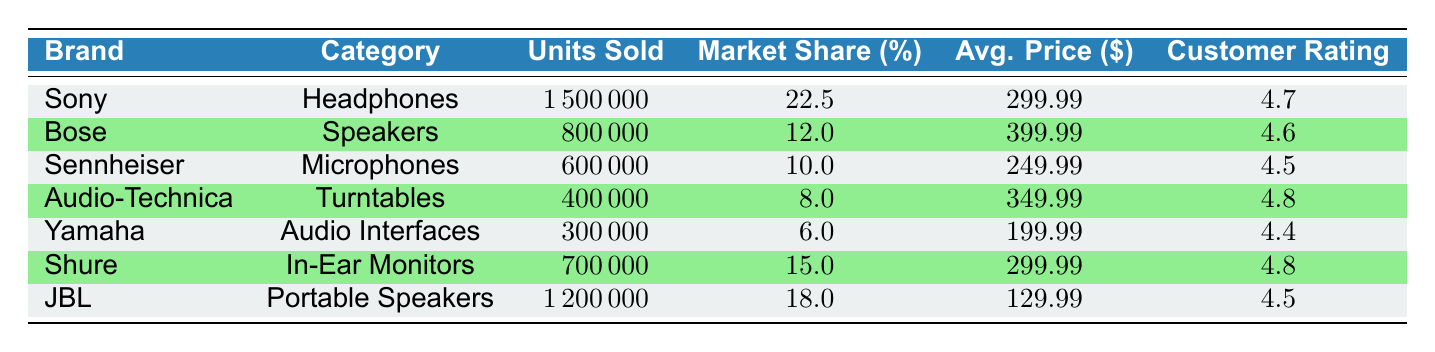What audio brand had the highest market share in 2022? From the table, Sony has a market share of 22.5%, which is the highest among all brands listed.
Answer: Sony How many units of Audio-Technica turntables were sold? Looking at the table, Audio-Technica sold 400,000 units of turntables.
Answer: 400000 Is the average price of JBL portable speakers lower than that of Yamaha audio interfaces? The average price of JBL portable speakers is 129.99, while Yamaha audio interfaces cost 199.99. Since 129.99 < 199.99, the statement is true.
Answer: Yes What is the total number of units sold for Shure in-ear monitors and Sennheiser microphones combined? Shure sold 700,000 units, and Sennheiser sold 600,000 units. Adding these together gives 700,000 + 600,000 = 1,300,000 units.
Answer: 1300000 Which brand achieved a customer rating of 4.8? The table shows that both Audio-Technica and Shure received a customer rating of 4.8.
Answer: Audio-Technica, Shure What brand has the second highest units sold after Sony? After checking the units sold, JBL has 1,200,000 units sold, making it the second highest, following Sony's 1,500,000 units.
Answer: JBL Did Bose have a higher average price compared to Sennheiser? The average price of Bose speakers is 399.99, and Sennheiser microphones are 249.99. Since 399.99 > 249.99, the answer is yes.
Answer: Yes Calculate the average units sold for all brands listed in the table. To find the average, add together all units sold (1,500,000 + 800,000 + 600,000 + 400,000 + 300,000 + 700,000 + 1,200,000 = 5,600,000) and divide by the number of brands (7), resulting in 5,600,000 / 7 = 800,000.
Answer: 800000 